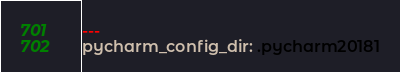<code> <loc_0><loc_0><loc_500><loc_500><_YAML_>---
pycharm_config_dir: .pycharm20181
</code> 